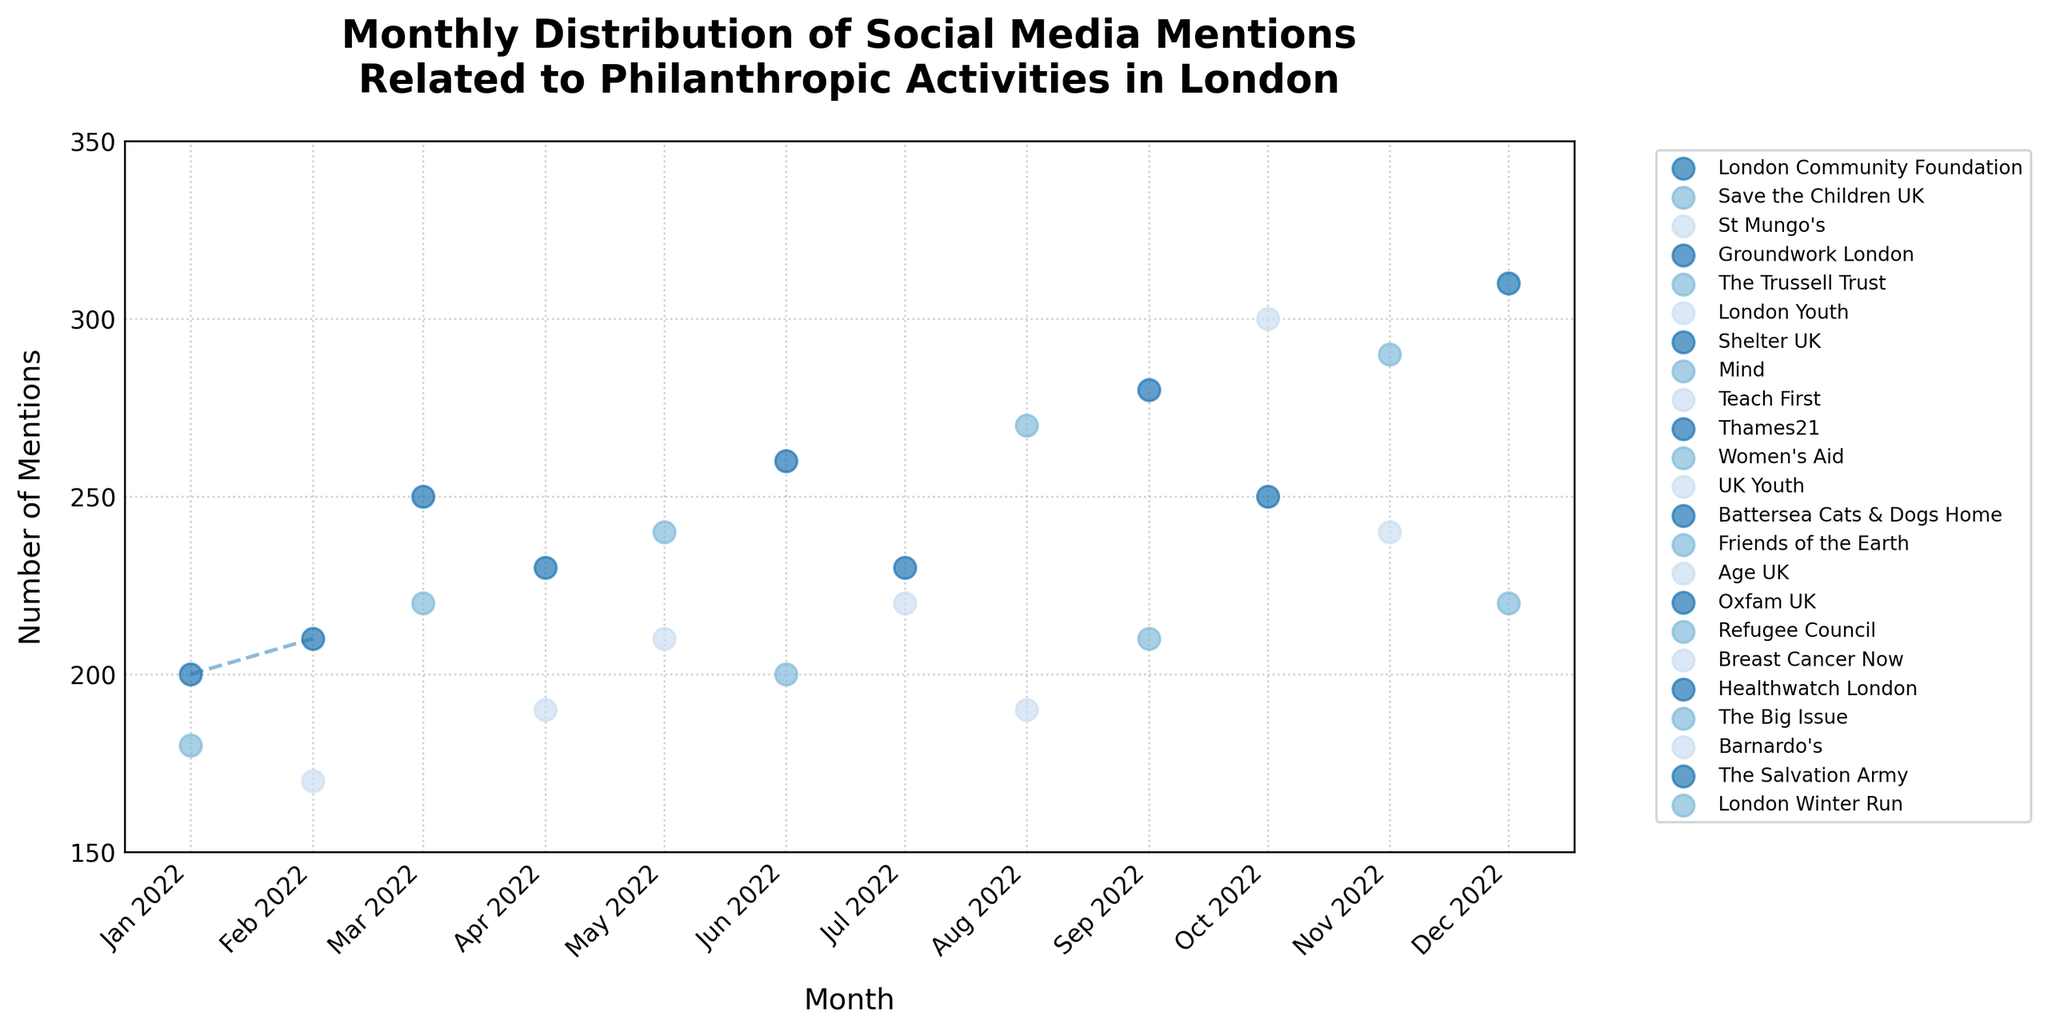What's the title of the plot? Look at the top of the figure, the title is prominently displayed there. It's a summary of what the plot represents.
Answer: Monthly Distribution of Social Media Mentions Related to Philanthropic Activities in London How many organizations are represented in the plot? Observe the legend at the side of the plot, which lists all the different organizations present in the data. Count these organizations.
Answer: 12 Which month had the highest number of mentions, and what was the organization? Identify the peak point on the y-axis that represents the highest number of mentions. Then, look at the corresponding month on the x-axis and refer to the legend to determine the organization.
Answer: December 2022, The Salvation Army Which organization had the most consistent number of mentions over the months? Consistency means less fluctuation in the number of mentions. Look at the lines representing each organization and find the one with the least variation in y-values across the months.
Answer: London Community Foundation Compare the mentions of #GreenLondon (Groundwork London) and #BreastCancerAwareness (Breast Cancer Now) in their corresponding months. Which has more mentions? Find the points for Groundwork London in March and Breast Cancer Now in October. Compare their y-values to determine which is higher.
Answer: Breast Cancer Now What is the total number of mentions for London Community Foundation across all months? Sum the y-values associated with the London Community Foundation across all months. Examine the points and lines for this organization and add up the mentions.
Answer: 410 How many times did any organization exceed 250 mentions in a month? Look at the y-axis and identify the points where the number of mentions is above 250. Count these instances.
Answer: 6 Which organization had the highest number of mentions in November? Look at the points plotted for November. Check the legend to identify the organization associated with the highest value in that month.
Answer: The Big Issue How does the trend in social media mentions for Save the Children UK compare to that of Teach First? Examine the line trends for Save the Children UK and Teach First. Compare their slopes and general shapes to describe if one is increasing, decreasing, or stable compared to the other.
Answer: Save the Children UK is stable, Teach First is increasing Which month shows the highest variance in the number of mentions across all organizations? Variance means the spread of data points. Check all the months and compare the spread of mentions for each organization. Find the month with the widest spread from the lowest to the highest number of mentions.
Answer: October 